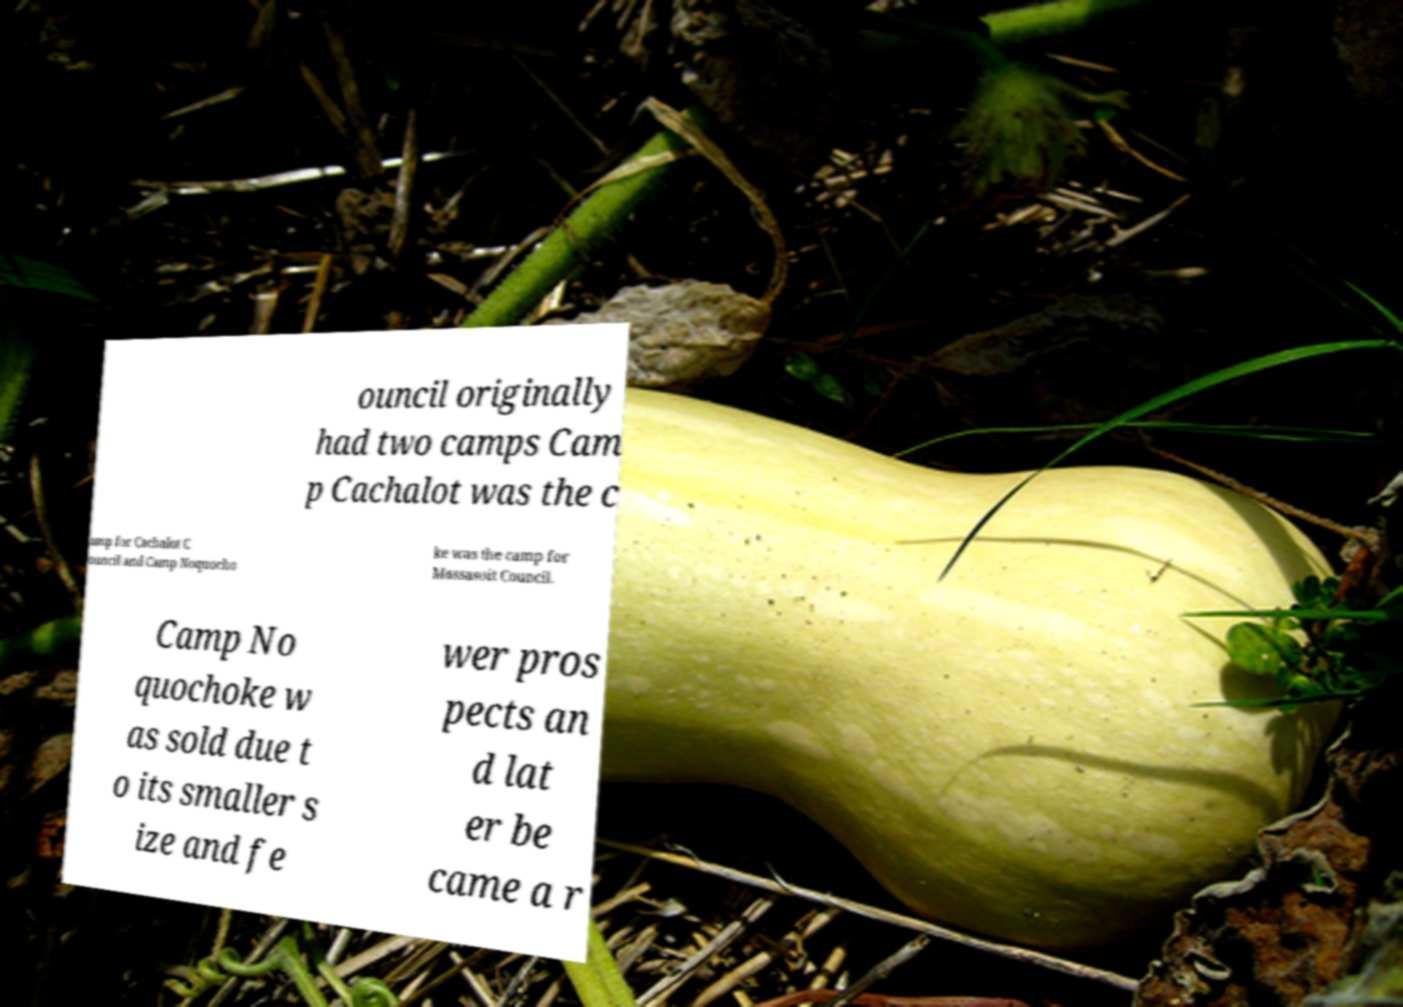Can you read and provide the text displayed in the image?This photo seems to have some interesting text. Can you extract and type it out for me? ouncil originally had two camps Cam p Cachalot was the c amp for Cachalot C ouncil and Camp Noquocho ke was the camp for Massasoit Council. Camp No quochoke w as sold due t o its smaller s ize and fe wer pros pects an d lat er be came a r 